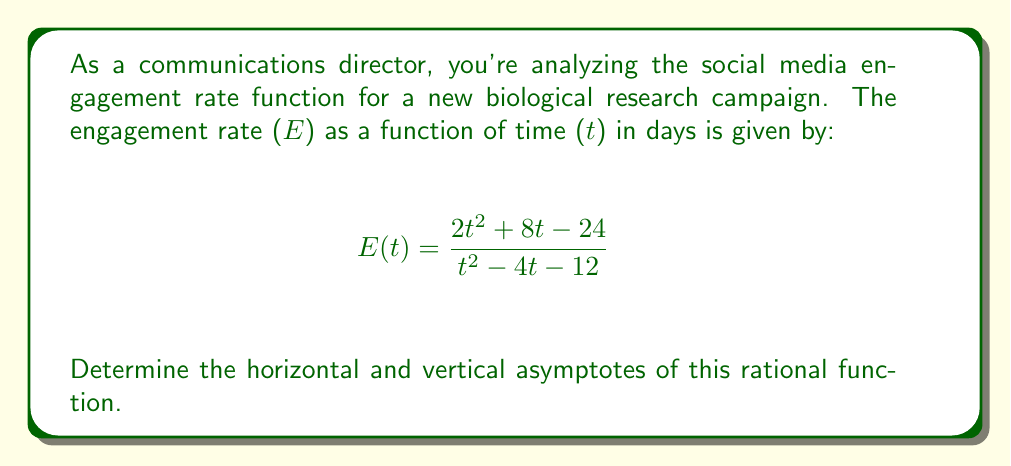Help me with this question. To find the asymptotes, we'll follow these steps:

1. Vertical asymptotes:
   Set the denominator to zero and solve for t.
   $$t^2 - 4t - 12 = 0$$
   $$(t - 6)(t + 2) = 0$$
   $$t = 6 \text{ or } t = -2$$
   
   The vertical asymptotes occur at t = 6 and t = -2.

2. Horizontal asymptote:
   Compare the degrees of the numerator and denominator.
   Both have degree 2, so we divide the leading coefficients:
   $$\lim_{t \to \infty} \frac{2t^2}{t^2} = 2$$
   
   The horizontal asymptote is y = 2.

3. To verify, we can use long division:
   $$\frac{2t^2 + 8t - 24}{t^2 - 4t - 12} = 2 + \frac{16t + 0}{t^2 - 4t - 12}$$
   
   This confirms the horizontal asymptote of y = 2 as t approaches infinity.
Answer: Vertical asymptotes: t = 6, t = -2; Horizontal asymptote: y = 2 